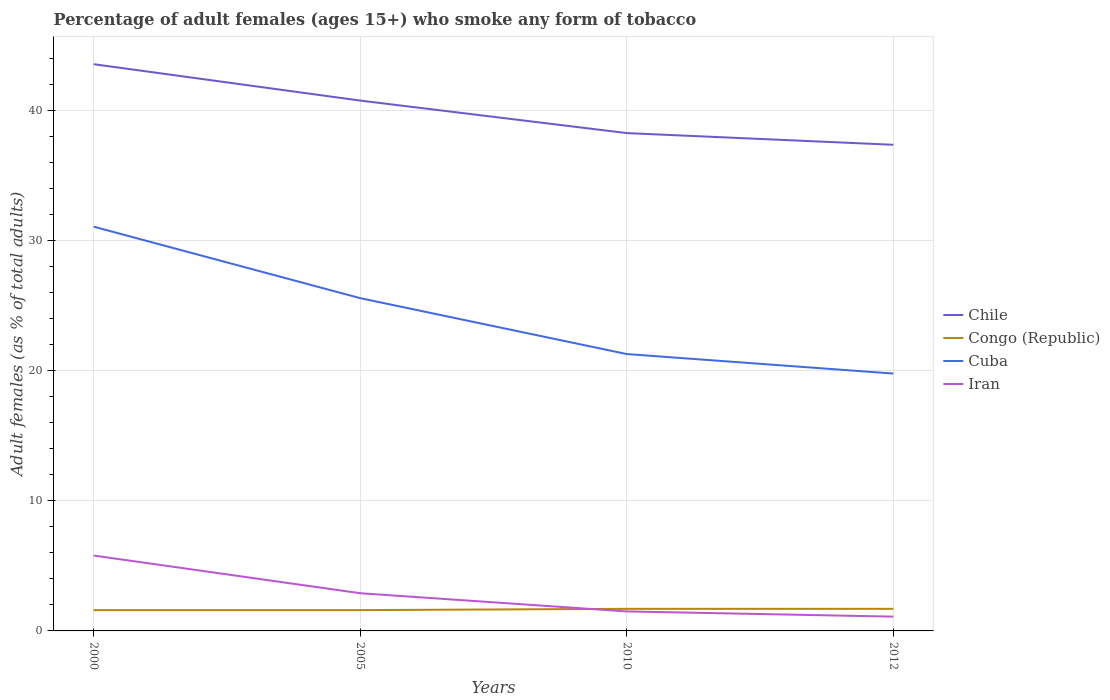How many different coloured lines are there?
Provide a short and direct response. 4. Across all years, what is the maximum percentage of adult females who smoke in Chile?
Give a very brief answer. 37.4. Is the percentage of adult females who smoke in Iran strictly greater than the percentage of adult females who smoke in Congo (Republic) over the years?
Your answer should be compact. No. How many lines are there?
Your response must be concise. 4. How many years are there in the graph?
Provide a short and direct response. 4. Does the graph contain grids?
Offer a very short reply. Yes. Where does the legend appear in the graph?
Your response must be concise. Center right. What is the title of the graph?
Your answer should be compact. Percentage of adult females (ages 15+) who smoke any form of tobacco. What is the label or title of the Y-axis?
Offer a terse response. Adult females (as % of total adults). What is the Adult females (as % of total adults) in Chile in 2000?
Provide a short and direct response. 43.6. What is the Adult females (as % of total adults) of Cuba in 2000?
Provide a short and direct response. 31.1. What is the Adult females (as % of total adults) in Chile in 2005?
Provide a short and direct response. 40.8. What is the Adult females (as % of total adults) in Congo (Republic) in 2005?
Your answer should be compact. 1.6. What is the Adult females (as % of total adults) of Cuba in 2005?
Your answer should be compact. 25.6. What is the Adult females (as % of total adults) in Iran in 2005?
Offer a very short reply. 2.9. What is the Adult females (as % of total adults) in Chile in 2010?
Make the answer very short. 38.3. What is the Adult females (as % of total adults) in Cuba in 2010?
Keep it short and to the point. 21.3. What is the Adult females (as % of total adults) of Iran in 2010?
Offer a very short reply. 1.5. What is the Adult females (as % of total adults) in Chile in 2012?
Provide a succinct answer. 37.4. What is the Adult females (as % of total adults) in Congo (Republic) in 2012?
Keep it short and to the point. 1.7. What is the Adult females (as % of total adults) in Cuba in 2012?
Keep it short and to the point. 19.8. Across all years, what is the maximum Adult females (as % of total adults) in Chile?
Your answer should be compact. 43.6. Across all years, what is the maximum Adult females (as % of total adults) in Cuba?
Offer a very short reply. 31.1. Across all years, what is the minimum Adult females (as % of total adults) in Chile?
Make the answer very short. 37.4. Across all years, what is the minimum Adult females (as % of total adults) in Cuba?
Keep it short and to the point. 19.8. What is the total Adult females (as % of total adults) of Chile in the graph?
Make the answer very short. 160.1. What is the total Adult females (as % of total adults) of Cuba in the graph?
Keep it short and to the point. 97.8. What is the difference between the Adult females (as % of total adults) in Chile in 2000 and that in 2005?
Your answer should be compact. 2.8. What is the difference between the Adult females (as % of total adults) in Congo (Republic) in 2000 and that in 2010?
Your answer should be very brief. -0.1. What is the difference between the Adult females (as % of total adults) in Iran in 2000 and that in 2012?
Give a very brief answer. 4.7. What is the difference between the Adult females (as % of total adults) of Chile in 2005 and that in 2010?
Provide a succinct answer. 2.5. What is the difference between the Adult females (as % of total adults) of Congo (Republic) in 2005 and that in 2010?
Make the answer very short. -0.1. What is the difference between the Adult females (as % of total adults) in Cuba in 2005 and that in 2010?
Provide a short and direct response. 4.3. What is the difference between the Adult females (as % of total adults) of Chile in 2005 and that in 2012?
Your answer should be very brief. 3.4. What is the difference between the Adult females (as % of total adults) of Cuba in 2005 and that in 2012?
Offer a very short reply. 5.8. What is the difference between the Adult females (as % of total adults) in Iran in 2005 and that in 2012?
Make the answer very short. 1.8. What is the difference between the Adult females (as % of total adults) of Chile in 2010 and that in 2012?
Provide a succinct answer. 0.9. What is the difference between the Adult females (as % of total adults) of Congo (Republic) in 2010 and that in 2012?
Provide a succinct answer. 0. What is the difference between the Adult females (as % of total adults) in Chile in 2000 and the Adult females (as % of total adults) in Congo (Republic) in 2005?
Your answer should be compact. 42. What is the difference between the Adult females (as % of total adults) in Chile in 2000 and the Adult females (as % of total adults) in Iran in 2005?
Offer a very short reply. 40.7. What is the difference between the Adult females (as % of total adults) in Cuba in 2000 and the Adult females (as % of total adults) in Iran in 2005?
Your response must be concise. 28.2. What is the difference between the Adult females (as % of total adults) of Chile in 2000 and the Adult females (as % of total adults) of Congo (Republic) in 2010?
Your answer should be compact. 41.9. What is the difference between the Adult females (as % of total adults) of Chile in 2000 and the Adult females (as % of total adults) of Cuba in 2010?
Your answer should be very brief. 22.3. What is the difference between the Adult females (as % of total adults) of Chile in 2000 and the Adult females (as % of total adults) of Iran in 2010?
Keep it short and to the point. 42.1. What is the difference between the Adult females (as % of total adults) in Congo (Republic) in 2000 and the Adult females (as % of total adults) in Cuba in 2010?
Ensure brevity in your answer.  -19.7. What is the difference between the Adult females (as % of total adults) of Cuba in 2000 and the Adult females (as % of total adults) of Iran in 2010?
Offer a terse response. 29.6. What is the difference between the Adult females (as % of total adults) of Chile in 2000 and the Adult females (as % of total adults) of Congo (Republic) in 2012?
Provide a short and direct response. 41.9. What is the difference between the Adult females (as % of total adults) in Chile in 2000 and the Adult females (as % of total adults) in Cuba in 2012?
Offer a very short reply. 23.8. What is the difference between the Adult females (as % of total adults) of Chile in 2000 and the Adult females (as % of total adults) of Iran in 2012?
Your answer should be compact. 42.5. What is the difference between the Adult females (as % of total adults) of Congo (Republic) in 2000 and the Adult females (as % of total adults) of Cuba in 2012?
Provide a succinct answer. -18.2. What is the difference between the Adult females (as % of total adults) in Congo (Republic) in 2000 and the Adult females (as % of total adults) in Iran in 2012?
Keep it short and to the point. 0.5. What is the difference between the Adult females (as % of total adults) of Chile in 2005 and the Adult females (as % of total adults) of Congo (Republic) in 2010?
Your answer should be compact. 39.1. What is the difference between the Adult females (as % of total adults) in Chile in 2005 and the Adult females (as % of total adults) in Cuba in 2010?
Provide a short and direct response. 19.5. What is the difference between the Adult females (as % of total adults) in Chile in 2005 and the Adult females (as % of total adults) in Iran in 2010?
Your response must be concise. 39.3. What is the difference between the Adult females (as % of total adults) of Congo (Republic) in 2005 and the Adult females (as % of total adults) of Cuba in 2010?
Give a very brief answer. -19.7. What is the difference between the Adult females (as % of total adults) in Cuba in 2005 and the Adult females (as % of total adults) in Iran in 2010?
Offer a very short reply. 24.1. What is the difference between the Adult females (as % of total adults) of Chile in 2005 and the Adult females (as % of total adults) of Congo (Republic) in 2012?
Your answer should be compact. 39.1. What is the difference between the Adult females (as % of total adults) of Chile in 2005 and the Adult females (as % of total adults) of Iran in 2012?
Give a very brief answer. 39.7. What is the difference between the Adult females (as % of total adults) in Congo (Republic) in 2005 and the Adult females (as % of total adults) in Cuba in 2012?
Your response must be concise. -18.2. What is the difference between the Adult females (as % of total adults) in Cuba in 2005 and the Adult females (as % of total adults) in Iran in 2012?
Provide a short and direct response. 24.5. What is the difference between the Adult females (as % of total adults) in Chile in 2010 and the Adult females (as % of total adults) in Congo (Republic) in 2012?
Keep it short and to the point. 36.6. What is the difference between the Adult females (as % of total adults) in Chile in 2010 and the Adult females (as % of total adults) in Iran in 2012?
Offer a terse response. 37.2. What is the difference between the Adult females (as % of total adults) of Congo (Republic) in 2010 and the Adult females (as % of total adults) of Cuba in 2012?
Keep it short and to the point. -18.1. What is the difference between the Adult females (as % of total adults) of Congo (Republic) in 2010 and the Adult females (as % of total adults) of Iran in 2012?
Your response must be concise. 0.6. What is the difference between the Adult females (as % of total adults) in Cuba in 2010 and the Adult females (as % of total adults) in Iran in 2012?
Offer a very short reply. 20.2. What is the average Adult females (as % of total adults) in Chile per year?
Offer a very short reply. 40.02. What is the average Adult females (as % of total adults) of Congo (Republic) per year?
Your answer should be compact. 1.65. What is the average Adult females (as % of total adults) of Cuba per year?
Your answer should be compact. 24.45. What is the average Adult females (as % of total adults) of Iran per year?
Your answer should be very brief. 2.83. In the year 2000, what is the difference between the Adult females (as % of total adults) of Chile and Adult females (as % of total adults) of Iran?
Ensure brevity in your answer.  37.8. In the year 2000, what is the difference between the Adult females (as % of total adults) in Congo (Republic) and Adult females (as % of total adults) in Cuba?
Keep it short and to the point. -29.5. In the year 2000, what is the difference between the Adult females (as % of total adults) of Congo (Republic) and Adult females (as % of total adults) of Iran?
Give a very brief answer. -4.2. In the year 2000, what is the difference between the Adult females (as % of total adults) in Cuba and Adult females (as % of total adults) in Iran?
Offer a terse response. 25.3. In the year 2005, what is the difference between the Adult females (as % of total adults) of Chile and Adult females (as % of total adults) of Congo (Republic)?
Ensure brevity in your answer.  39.2. In the year 2005, what is the difference between the Adult females (as % of total adults) of Chile and Adult females (as % of total adults) of Iran?
Provide a short and direct response. 37.9. In the year 2005, what is the difference between the Adult females (as % of total adults) in Congo (Republic) and Adult females (as % of total adults) in Iran?
Offer a very short reply. -1.3. In the year 2005, what is the difference between the Adult females (as % of total adults) in Cuba and Adult females (as % of total adults) in Iran?
Offer a very short reply. 22.7. In the year 2010, what is the difference between the Adult females (as % of total adults) in Chile and Adult females (as % of total adults) in Congo (Republic)?
Your response must be concise. 36.6. In the year 2010, what is the difference between the Adult females (as % of total adults) in Chile and Adult females (as % of total adults) in Iran?
Your answer should be compact. 36.8. In the year 2010, what is the difference between the Adult females (as % of total adults) of Congo (Republic) and Adult females (as % of total adults) of Cuba?
Offer a terse response. -19.6. In the year 2010, what is the difference between the Adult females (as % of total adults) of Congo (Republic) and Adult females (as % of total adults) of Iran?
Offer a terse response. 0.2. In the year 2010, what is the difference between the Adult females (as % of total adults) in Cuba and Adult females (as % of total adults) in Iran?
Give a very brief answer. 19.8. In the year 2012, what is the difference between the Adult females (as % of total adults) of Chile and Adult females (as % of total adults) of Congo (Republic)?
Offer a very short reply. 35.7. In the year 2012, what is the difference between the Adult females (as % of total adults) of Chile and Adult females (as % of total adults) of Iran?
Your answer should be very brief. 36.3. In the year 2012, what is the difference between the Adult females (as % of total adults) of Congo (Republic) and Adult females (as % of total adults) of Cuba?
Ensure brevity in your answer.  -18.1. In the year 2012, what is the difference between the Adult females (as % of total adults) of Congo (Republic) and Adult females (as % of total adults) of Iran?
Make the answer very short. 0.6. What is the ratio of the Adult females (as % of total adults) in Chile in 2000 to that in 2005?
Make the answer very short. 1.07. What is the ratio of the Adult females (as % of total adults) of Congo (Republic) in 2000 to that in 2005?
Keep it short and to the point. 1. What is the ratio of the Adult females (as % of total adults) of Cuba in 2000 to that in 2005?
Offer a terse response. 1.21. What is the ratio of the Adult females (as % of total adults) in Iran in 2000 to that in 2005?
Ensure brevity in your answer.  2. What is the ratio of the Adult females (as % of total adults) of Chile in 2000 to that in 2010?
Provide a succinct answer. 1.14. What is the ratio of the Adult females (as % of total adults) in Congo (Republic) in 2000 to that in 2010?
Your response must be concise. 0.94. What is the ratio of the Adult females (as % of total adults) in Cuba in 2000 to that in 2010?
Your answer should be very brief. 1.46. What is the ratio of the Adult females (as % of total adults) of Iran in 2000 to that in 2010?
Provide a succinct answer. 3.87. What is the ratio of the Adult females (as % of total adults) in Chile in 2000 to that in 2012?
Your response must be concise. 1.17. What is the ratio of the Adult females (as % of total adults) of Cuba in 2000 to that in 2012?
Ensure brevity in your answer.  1.57. What is the ratio of the Adult females (as % of total adults) of Iran in 2000 to that in 2012?
Offer a terse response. 5.27. What is the ratio of the Adult females (as % of total adults) in Chile in 2005 to that in 2010?
Offer a very short reply. 1.07. What is the ratio of the Adult females (as % of total adults) in Cuba in 2005 to that in 2010?
Offer a very short reply. 1.2. What is the ratio of the Adult females (as % of total adults) in Iran in 2005 to that in 2010?
Ensure brevity in your answer.  1.93. What is the ratio of the Adult females (as % of total adults) in Chile in 2005 to that in 2012?
Make the answer very short. 1.09. What is the ratio of the Adult females (as % of total adults) of Cuba in 2005 to that in 2012?
Your answer should be very brief. 1.29. What is the ratio of the Adult females (as % of total adults) of Iran in 2005 to that in 2012?
Offer a very short reply. 2.64. What is the ratio of the Adult females (as % of total adults) in Chile in 2010 to that in 2012?
Your response must be concise. 1.02. What is the ratio of the Adult females (as % of total adults) in Cuba in 2010 to that in 2012?
Provide a short and direct response. 1.08. What is the ratio of the Adult females (as % of total adults) in Iran in 2010 to that in 2012?
Offer a terse response. 1.36. What is the difference between the highest and the second highest Adult females (as % of total adults) of Congo (Republic)?
Give a very brief answer. 0. What is the difference between the highest and the second highest Adult females (as % of total adults) in Iran?
Give a very brief answer. 2.9. What is the difference between the highest and the lowest Adult females (as % of total adults) of Cuba?
Your answer should be compact. 11.3. What is the difference between the highest and the lowest Adult females (as % of total adults) in Iran?
Make the answer very short. 4.7. 